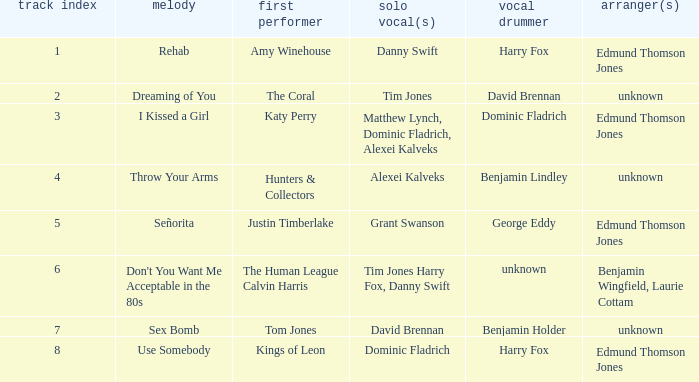Who is the percussionist for The Coral? David Brennan. 